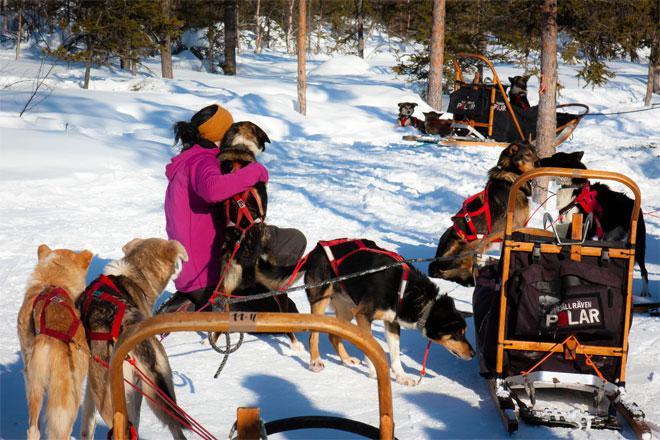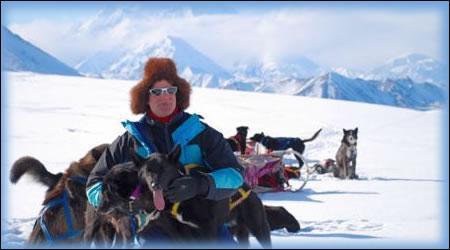The first image is the image on the left, the second image is the image on the right. Examine the images to the left and right. Is the description "One of the images shows exactly two dogs pulling the sled." accurate? Answer yes or no. No. The first image is the image on the left, the second image is the image on the right. Examine the images to the left and right. Is the description "A crowd of people stand packed together on the left to watch a sled dog race, in one image." accurate? Answer yes or no. No. 